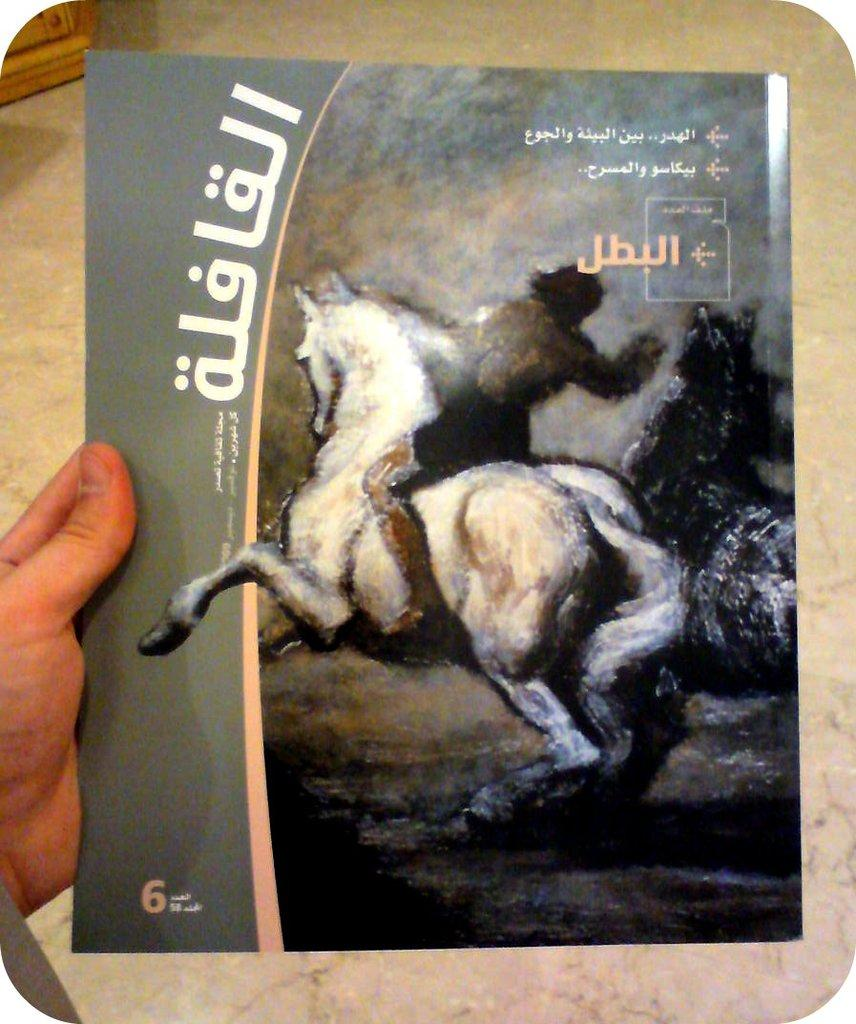<image>
Create a compact narrative representing the image presented. Book with a horse on it and number 6 from another country. 